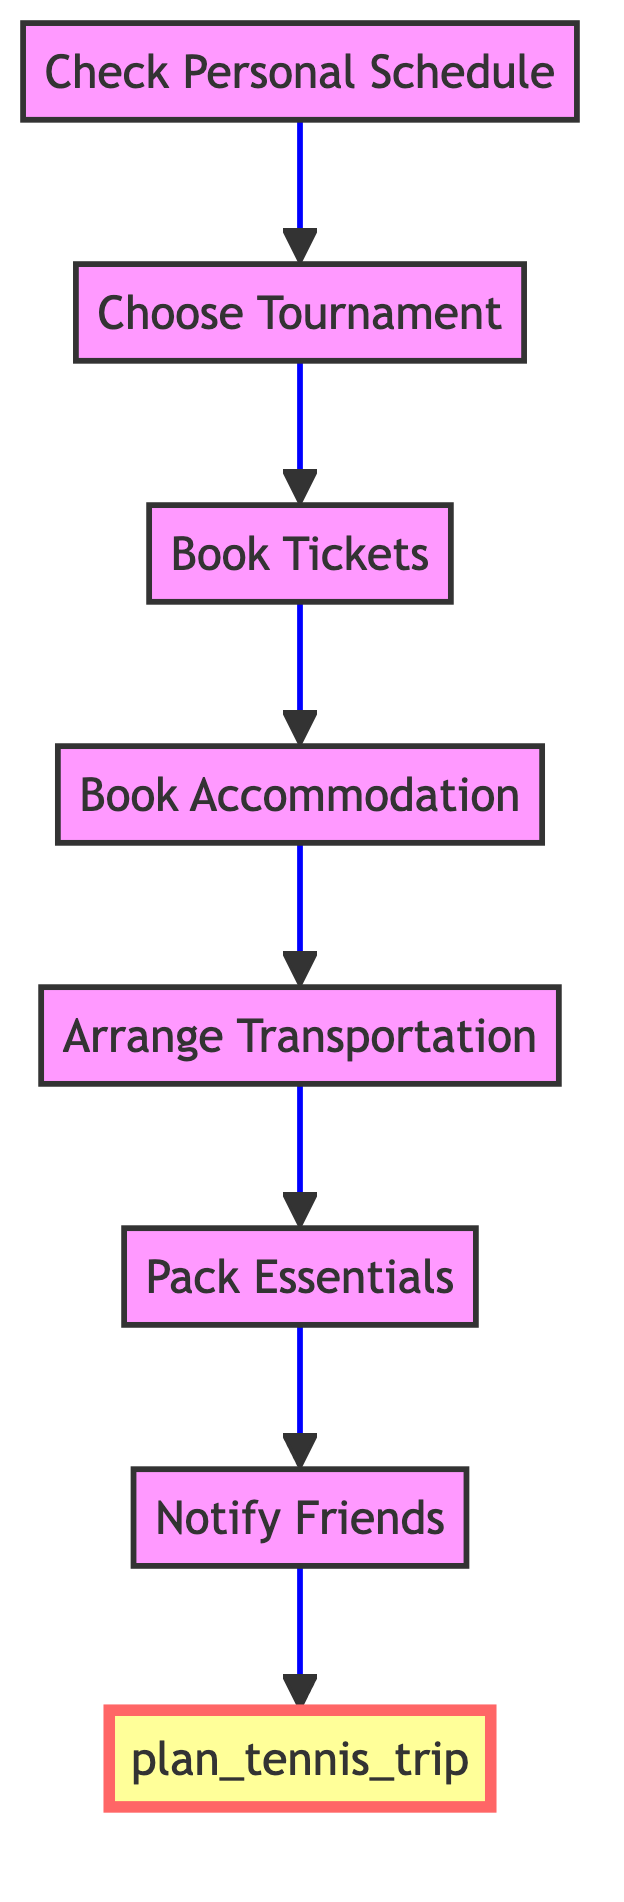What is the first step in planning a tennis trip according to the diagram? The first step in planning a tennis trip is to check the personal schedule. This is derived from the flowchart where the first node in the flow is labeled "Check Personal Schedule," indicating it is the initial action to be taken.
Answer: Check Personal Schedule How many total steps are involved in planning the tennis trip? The diagram outlines a total of seven steps involved in the trip planning process. By counting each node from the starting point to the final action, we see there are seven distinct actions to take.
Answer: Seven What step comes after booking tickets? The step that follows booking tickets is booking accommodation. Following the flow from the "Book Tickets" node, the arrow points directly to the "Book Accommodation" node, indicating the next action.
Answer: Book Accommodation Which step specifically excludes events featuring Jessica Pegula? The step that specifically excludes events where Jessica Pegula is primarily featured is "Choose Tournament." This is explicitly stated in the description of that step, indicating a preference to skip such tournaments.
Answer: Choose Tournament What actions are taken after packing essentials? After packing essentials, the next action is to notify friends. Tracing the flow from the "Pack Essentials" step, the arrow leads directly to the "Notify Friends" node.
Answer: Notify Friends What are the direct relationships between the 'arrange transportation' step and 'book accommodation' step? The direct relationship between these two steps is sequential; after booking accommodation, you proceed to arrange transportation. The flowchart displays an arrow leading from "Book Accommodation" directly to "Arrange Transportation," indicating their order in the planning process.
Answer: Sequential What is the overarching function represented in the diagram? The overarching function represented in the diagram is the "plan tennis trip" function. This is indicated by the final node labeled "plan_tennis_trip," which signifies the overall purpose of the steps delineated above it.
Answer: Plan tennis trip What would happen if you skip checking the personal schedule? Skipping the personal schedule step could result in scheduling conflicts not being recognized until later stages of planning, potentially disrupting the trip. The flowchart indicates that you cannot effectively proceed with planning without first checking personal availability.
Answer: Potential scheduling conflicts 